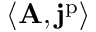Convert formula to latex. <formula><loc_0><loc_0><loc_500><loc_500>\langle A , j ^ { p } \rangle</formula> 